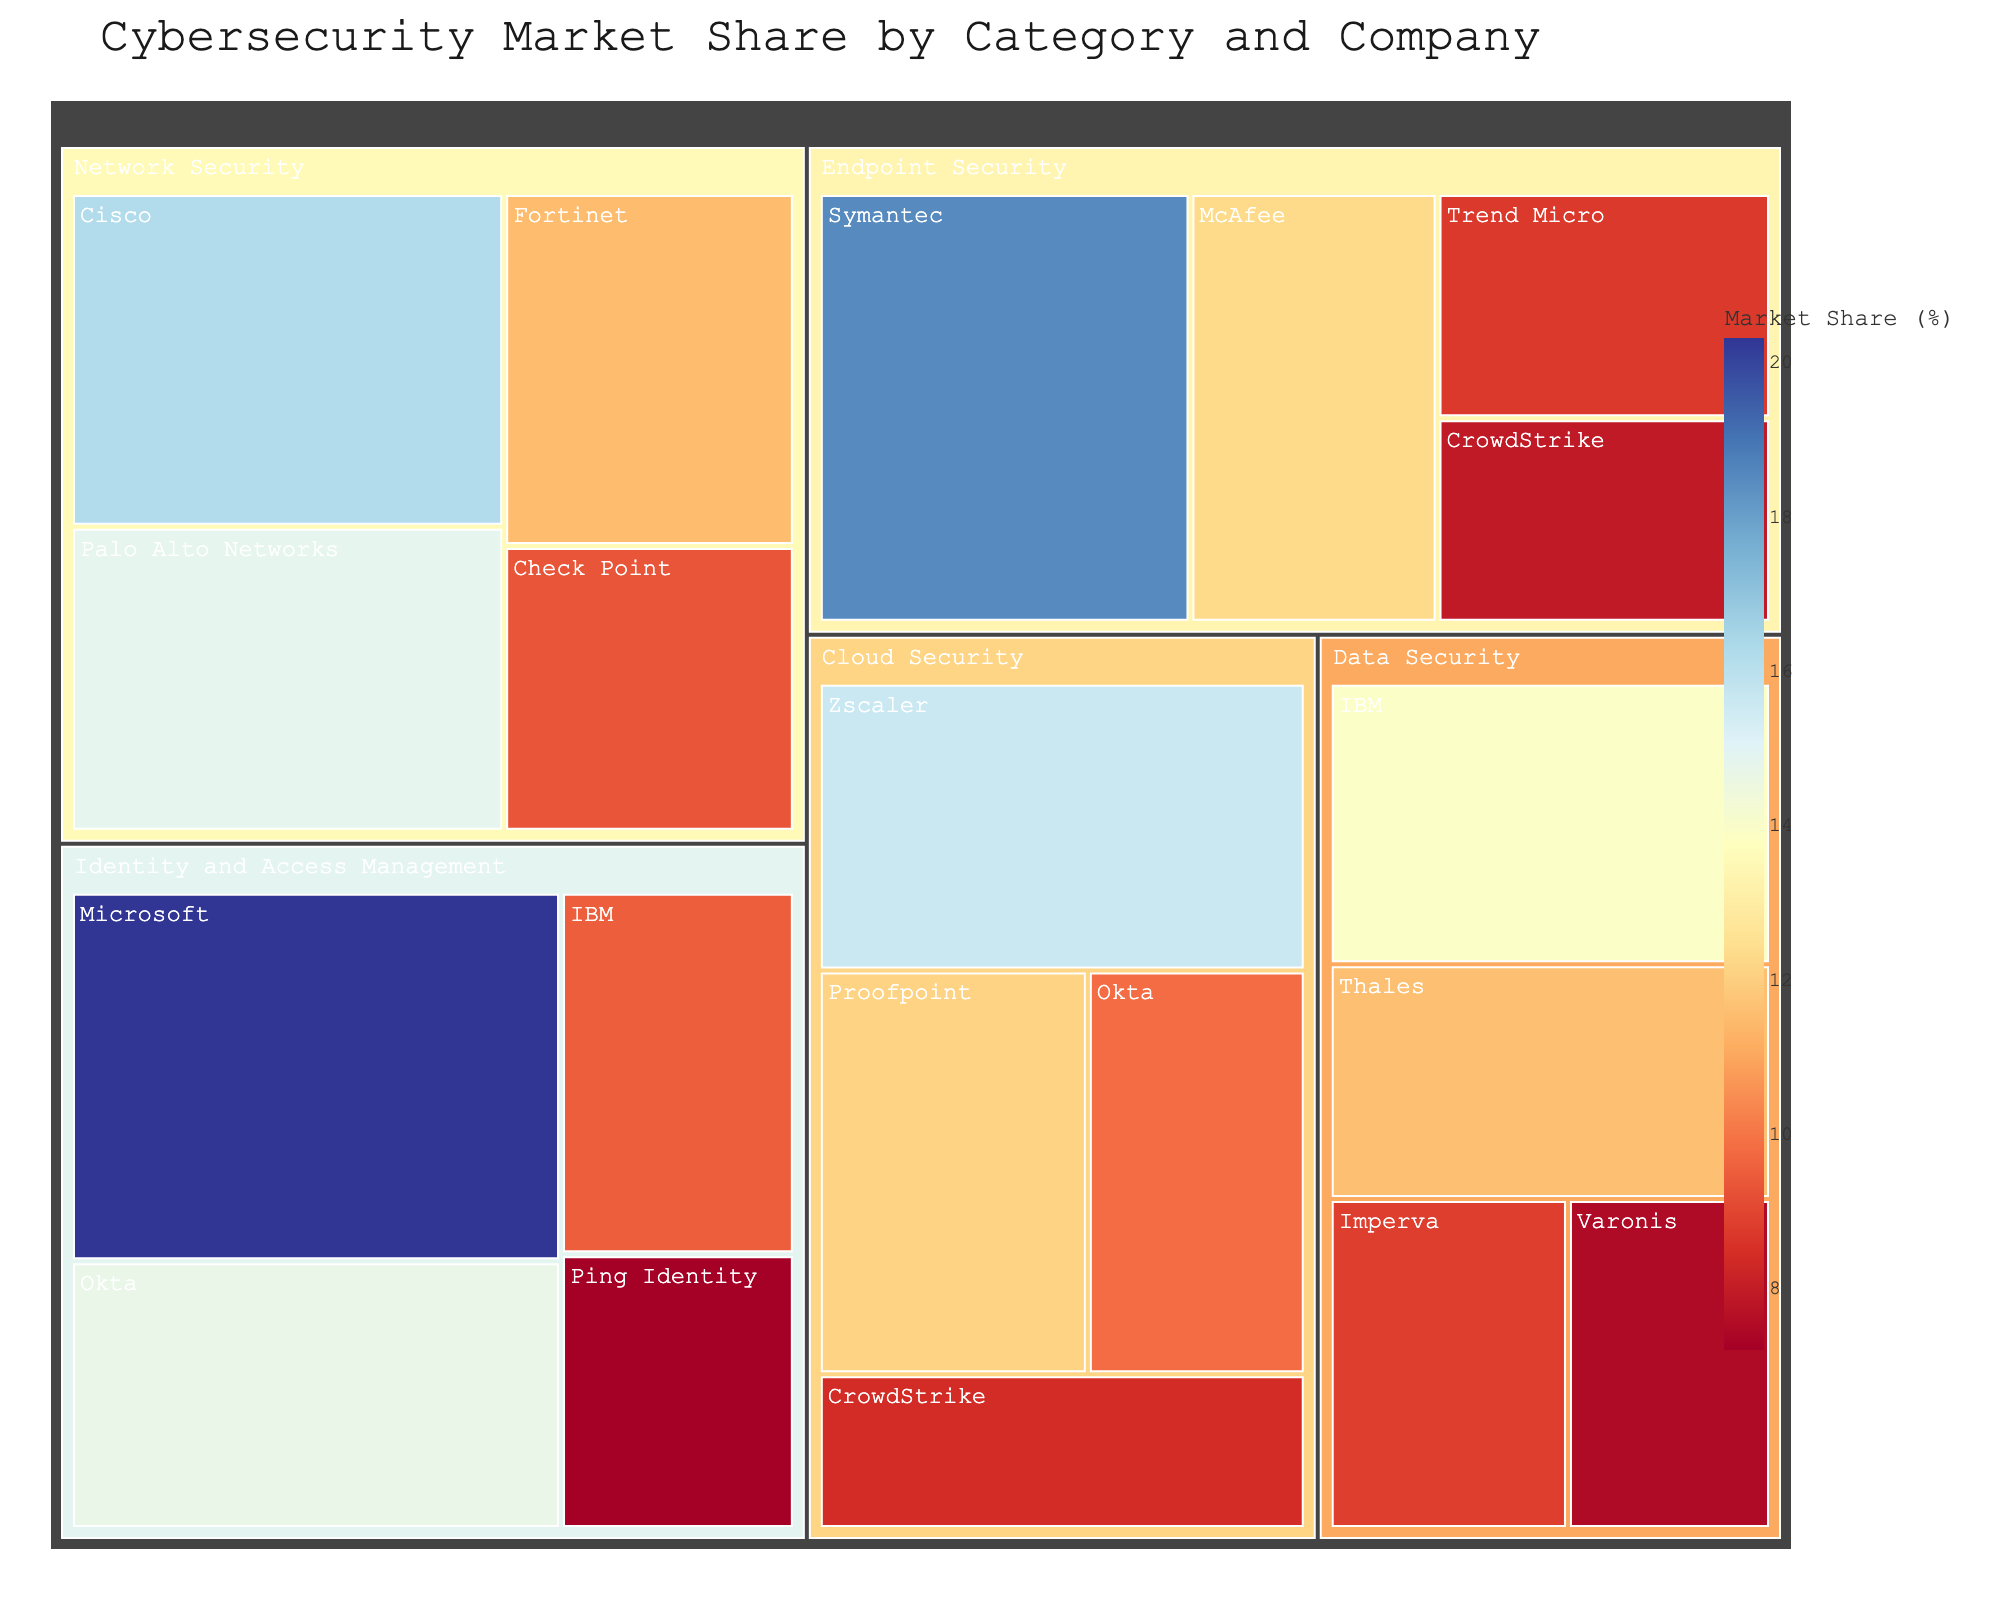What's the title of the treemap? The title is displayed prominently at the top of the figure.
Answer: Cybersecurity Market Share by Category and Company Which company has the largest market share in Identity and Access Management? Look at the section for Identity and Access Management; the largest rectangle represents the company with the highest market share.
Answer: Microsoft What is the combined market share of Symantec and McAfee in Endpoint Security? Identify the market shares of Symantec (18.5%) and McAfee (12.3%), then sum them up: 18.5 + 12.3.
Answer: 30.8% Which company appears in both the Endpoint Security and Cloud Security categories? Scan the labels in each category to find a company name that repeats.
Answer: CrowdStrike Compare the market shares of Cisco and Palo Alto Networks in Network Security. Which one is higher? Look at the size of the rectangles for Cisco (16.2%) and Palo Alto Networks (14.8%) in the Network Security section.
Answer: Cisco What is the total market share occupied by the Data Security category? Sum the market shares of all companies in the Data Security category: IBM (13.9%), Thales (11.6%), Imperva (8.8%), Varonis (7.5%).
Answer: 41.8% Which product category has the smallest market share for its leading company? Compare the leading company's market share across all categories: Endpoint Security (Symantec, 18.5%), Network Security (Cisco, 16.2%), Cloud Security (Zscaler, 15.6%), Identity and Access Management (Microsoft, 20.3%), Data Security (IBM, 13.9%).
Answer: Data Security Is the market share of Okta in Identity and Access Management greater than its share in Cloud Security? Compare Okta’s market share in Identity and Access Management (14.7%) with that in Cloud Security (9.8%).
Answer: Yes How much larger is Microsoft's market share in Identity and Access Management compared to Ping Identity's? Subtract Ping Identity's market share (7.2%) from Microsoft's (20.3%) in Identity and Access Management.
Answer: 13.1% Which category has the most companies represented on the treemap? Count the number of companies in each category: Endpoint Security (Symantec, McAfee, Trend Micro, CrowdStrike), Network Security (Cisco, Palo Alto Networks, Fortinet, Check Point), Cloud Security (Zscaler, Proofpoint, Okta, CrowdStrike), Identity and Access Management (Microsoft, Okta, IBM, Ping Identity), Data Security (IBM, Thales, Imperva, Varonis).
Answer: Endpoint Security 